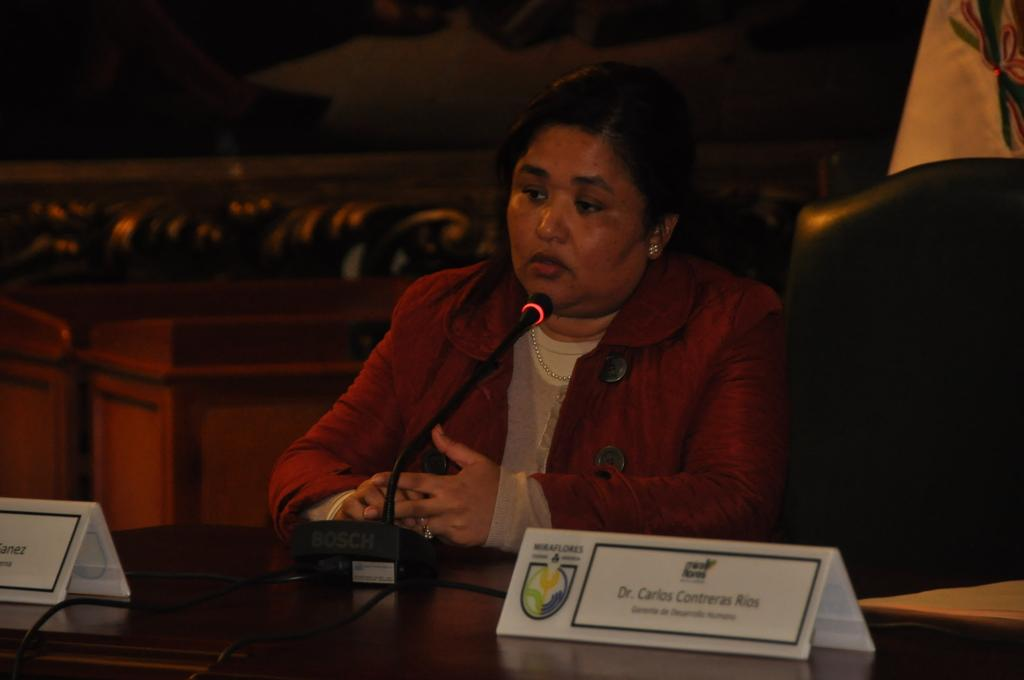Who or what is the main subject in the image? There is a person in the image. What is the person doing or standing near in the image? The person is in front of a podium. What is on the podium in the image? There is a board on the podium. How many cows are visible behind the person in the image? There are no cows visible in the image. What type of stretch is the person performing in the image? The person is not performing any stretch in the image; they are standing in front of a podium. 